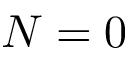<formula> <loc_0><loc_0><loc_500><loc_500>N = 0</formula> 